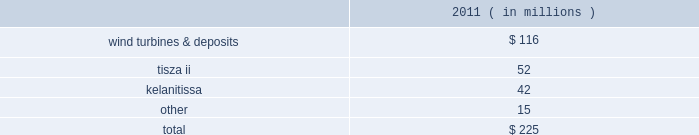The aes corporation notes to consolidated financial statements 2014 ( continued ) december 31 , 2011 , 2010 , and 2009 20 .
Impairment expense asset impairment asset impairment expense for the year ended december 31 , 2011 consisted of : ( in millions ) .
Wind turbines & deposits 2014during the third quarter of 2011 , the company evaluated the future use of certain wind turbines held in storage pending their installation .
Due to reduced wind turbine market pricing and advances in turbine technology , the company determined it was more likely than not that the turbines would be sold significantly before the end of their previously estimated useful lives .
In addition , the company has concluded that more likely than not non-refundable deposits it had made in prior years to a turbine manufacturer for the purchase of wind turbines are not recoverable .
The company determined it was more likely than not that it would not proceed with the purchase of turbines due to the availability of more advanced and lower cost turbines in the market .
These developments were more likely than not as of september 30 , 2011 and as a result were considered impairment indicators and the company determined that an impairment had occurred as of september 30 , 2011 as the aggregate carrying amount of $ 161 million of these assets was not recoverable and was reduced to their estimated fair value of $ 45 million determined under the market approach .
This resulted in asset impairment expense of $ 116 million .
Wind generation is reported in the corporate and other segment .
In january 2012 , the company forfeited the deposits for which a full impairment charge was recognized in the third quarter of 2011 , and there is no obligation for further payments under the related turbine supply agreement .
Additionally , the company sold some of the turbines held in storage during the fourth quarter of 2011 and is continuing to evaluate the future use of the turbines held in storage .
The company determined it is more likely than not that they will be sold , however they are not being actively marketed for sale at this time as the company is reconsidering the potential use of the turbines in light of recent development activity at one of its advance stage development projects .
It is reasonably possible that the turbines could incur further loss in value due to changing market conditions and advances in technology .
Tisza ii 2014during the fourth quarter of 2011 , tisza ii , a 900 mw gas and oil-fired generation plant in hungary entered into annual negotiations with its offtaker .
As a result of these negotiations , as well as the further deterioration of the economic environment in hungary , the company determined that an indicator of impairment existed at december 31 , 2011 .
Thus , the company performed an asset impairment test and determined that based on the undiscounted cash flow analysis , the carrying amount of tisza ii asset group was not recoverable .
The fair value of the asset group was then determined using a discounted cash flow analysis .
The carrying value of the tisza ii asset group of $ 94 million exceeded the fair value of $ 42 million resulting in the recognition of asset impairment expense of $ 52 million during the three months ended december 31 , 2011 .
Tisza ii is reported in the europe generation reportable segment .
Kelanitissa 2014in 2011 , the company recognized asset impairment expense of $ 42 million for the long-lived assets of kelanitissa , our diesel-fired generation plant in sri lanka .
We have continued to evaluate the recoverability of our long-lived assets at kelanitissa as a result of both the existing government regulation which .
During 2011 , what percent of the tisza ii asset group was written off? 
Computations: (52 / 94)
Answer: 0.55319. 